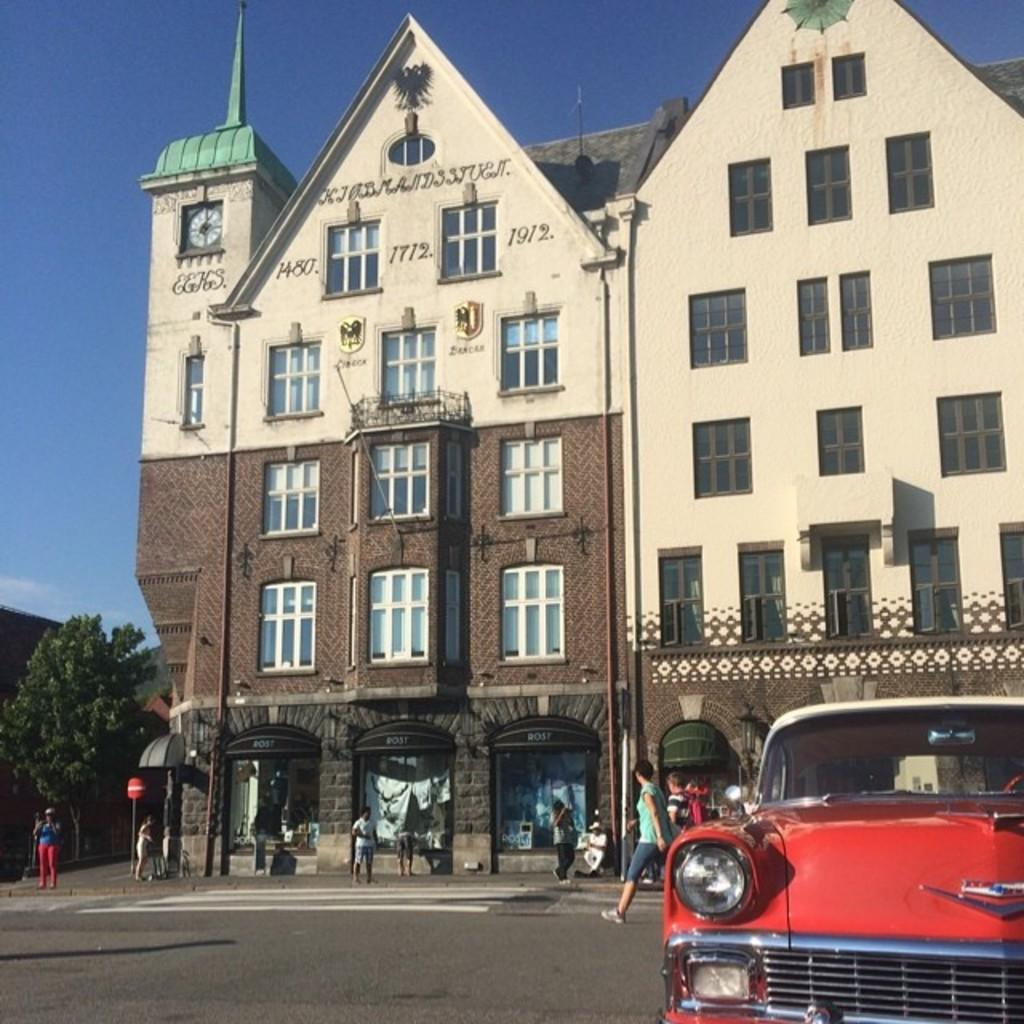What is the main subject of the image? There is a vehicle in the image. What else can be seen on the road in the image? There are people on the road in the image. What structures are visible in the image? There are buildings in the image. What type of natural elements can be seen in the image? There are trees in the image. Can you describe any other objects in the image? There are some objects in the image. What is visible in the background of the image? The sky is visible in the background of the image. What type of breakfast is being served on the vehicle in the image? There is no breakfast visible in the image; it only features a vehicle, people, buildings, trees, and other objects. Can you tell me how many dogs are present in the image? There are no dogs present in the image. 